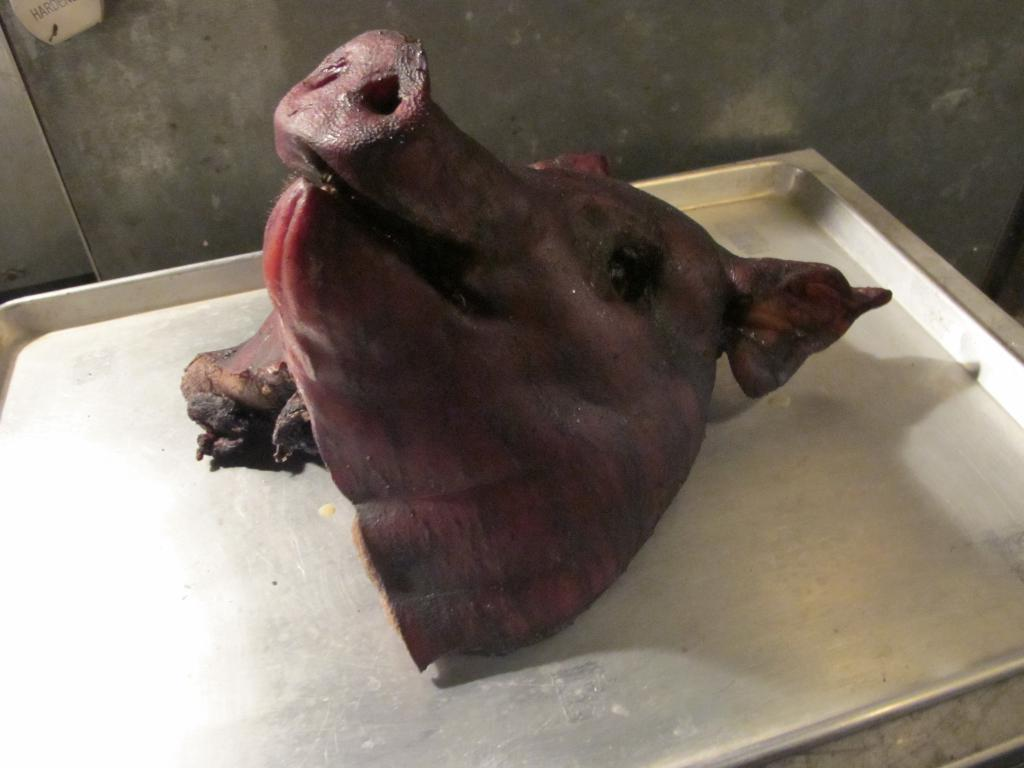What is the main subject of the image? The main subject of the image is the head of an animal on a tray. Can you describe the background of the image? There is a wall in the background of the image. What type of substance is the vase made of in the image? There is no vase present in the image, so it is not possible to determine what substance it might be made of. 